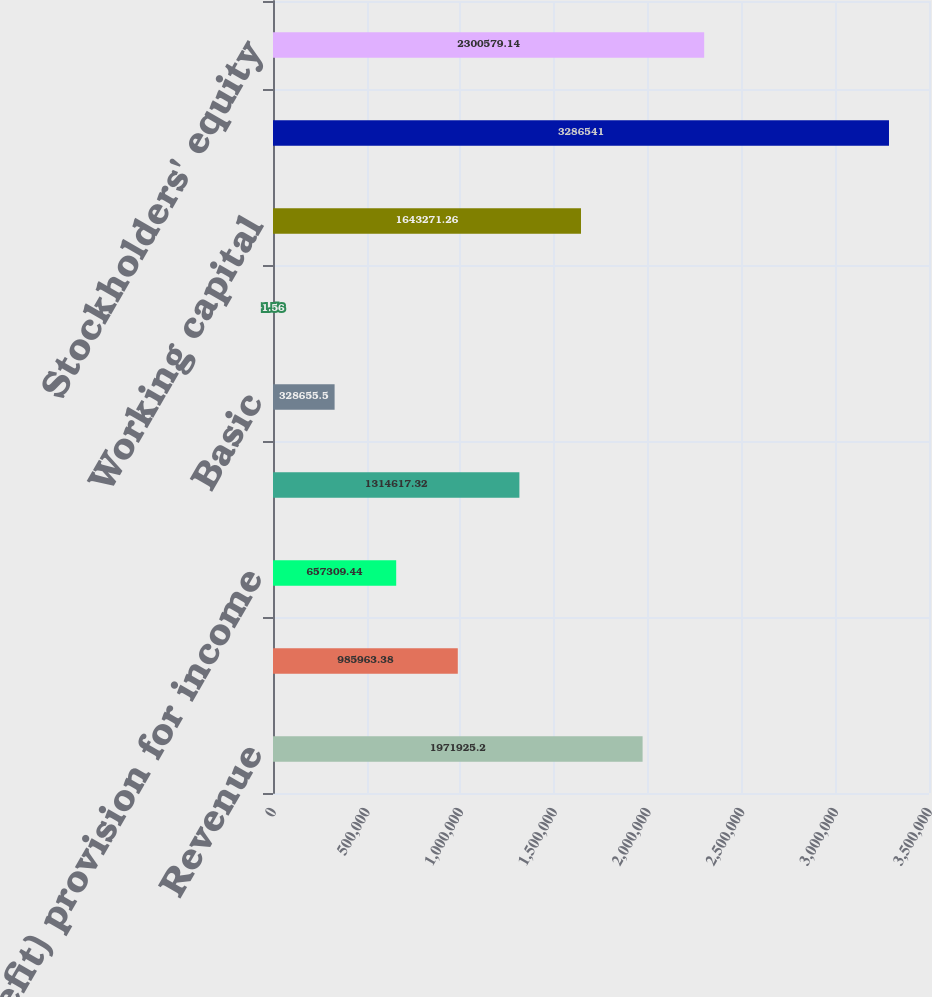<chart> <loc_0><loc_0><loc_500><loc_500><bar_chart><fcel>Revenue<fcel>Income before provisions for<fcel>(Benefit) provision for income<fcel>Net income<fcel>Basic<fcel>Diluted<fcel>Working capital<fcel>Total assets<fcel>Stockholders' equity<nl><fcel>1.97193e+06<fcel>985963<fcel>657309<fcel>1.31462e+06<fcel>328656<fcel>1.56<fcel>1.64327e+06<fcel>3.28654e+06<fcel>2.30058e+06<nl></chart> 